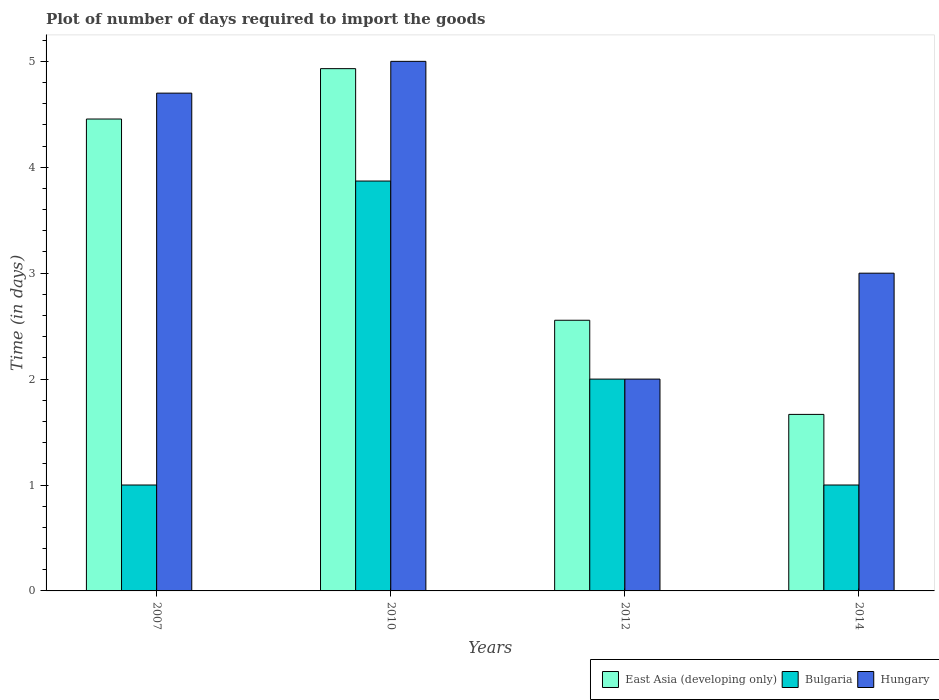How many bars are there on the 2nd tick from the left?
Give a very brief answer. 3. How many bars are there on the 1st tick from the right?
Give a very brief answer. 3. In how many cases, is the number of bars for a given year not equal to the number of legend labels?
Make the answer very short. 0. Across all years, what is the maximum time required to import goods in Bulgaria?
Offer a terse response. 3.87. Across all years, what is the minimum time required to import goods in East Asia (developing only)?
Your answer should be very brief. 1.67. In which year was the time required to import goods in Bulgaria maximum?
Offer a very short reply. 2010. What is the total time required to import goods in East Asia (developing only) in the graph?
Ensure brevity in your answer.  13.61. What is the difference between the time required to import goods in East Asia (developing only) in 2010 and that in 2014?
Keep it short and to the point. 3.26. What is the difference between the time required to import goods in Bulgaria in 2014 and the time required to import goods in East Asia (developing only) in 2012?
Your response must be concise. -1.56. What is the average time required to import goods in Hungary per year?
Keep it short and to the point. 3.67. In the year 2010, what is the difference between the time required to import goods in Hungary and time required to import goods in Bulgaria?
Your answer should be compact. 1.13. In how many years, is the time required to import goods in East Asia (developing only) greater than 2.6 days?
Provide a succinct answer. 2. What is the ratio of the time required to import goods in Hungary in 2007 to that in 2010?
Your response must be concise. 0.94. Is the time required to import goods in Hungary in 2012 less than that in 2014?
Your answer should be compact. Yes. What is the difference between the highest and the second highest time required to import goods in Hungary?
Keep it short and to the point. 0.3. What is the difference between the highest and the lowest time required to import goods in Hungary?
Provide a short and direct response. 3. In how many years, is the time required to import goods in Bulgaria greater than the average time required to import goods in Bulgaria taken over all years?
Your response must be concise. 2. Is the sum of the time required to import goods in East Asia (developing only) in 2007 and 2010 greater than the maximum time required to import goods in Bulgaria across all years?
Your answer should be very brief. Yes. How many years are there in the graph?
Ensure brevity in your answer.  4. What is the difference between two consecutive major ticks on the Y-axis?
Offer a terse response. 1. Are the values on the major ticks of Y-axis written in scientific E-notation?
Your response must be concise. No. Does the graph contain any zero values?
Make the answer very short. No. Does the graph contain grids?
Your response must be concise. No. What is the title of the graph?
Your response must be concise. Plot of number of days required to import the goods. Does "St. Martin (French part)" appear as one of the legend labels in the graph?
Provide a short and direct response. No. What is the label or title of the X-axis?
Make the answer very short. Years. What is the label or title of the Y-axis?
Your answer should be compact. Time (in days). What is the Time (in days) in East Asia (developing only) in 2007?
Your answer should be very brief. 4.46. What is the Time (in days) of Bulgaria in 2007?
Provide a succinct answer. 1. What is the Time (in days) in Hungary in 2007?
Offer a very short reply. 4.7. What is the Time (in days) in East Asia (developing only) in 2010?
Provide a short and direct response. 4.93. What is the Time (in days) of Bulgaria in 2010?
Offer a very short reply. 3.87. What is the Time (in days) in East Asia (developing only) in 2012?
Your response must be concise. 2.56. What is the Time (in days) of Bulgaria in 2012?
Offer a terse response. 2. What is the Time (in days) of East Asia (developing only) in 2014?
Give a very brief answer. 1.67. What is the Time (in days) of Bulgaria in 2014?
Ensure brevity in your answer.  1. Across all years, what is the maximum Time (in days) of East Asia (developing only)?
Provide a succinct answer. 4.93. Across all years, what is the maximum Time (in days) in Bulgaria?
Give a very brief answer. 3.87. Across all years, what is the maximum Time (in days) of Hungary?
Ensure brevity in your answer.  5. Across all years, what is the minimum Time (in days) in East Asia (developing only)?
Provide a short and direct response. 1.67. Across all years, what is the minimum Time (in days) of Bulgaria?
Your response must be concise. 1. Across all years, what is the minimum Time (in days) of Hungary?
Your answer should be very brief. 2. What is the total Time (in days) of East Asia (developing only) in the graph?
Offer a terse response. 13.61. What is the total Time (in days) in Bulgaria in the graph?
Make the answer very short. 7.87. What is the difference between the Time (in days) in East Asia (developing only) in 2007 and that in 2010?
Ensure brevity in your answer.  -0.48. What is the difference between the Time (in days) in Bulgaria in 2007 and that in 2010?
Your answer should be compact. -2.87. What is the difference between the Time (in days) of Hungary in 2007 and that in 2010?
Give a very brief answer. -0.3. What is the difference between the Time (in days) in East Asia (developing only) in 2007 and that in 2012?
Your answer should be compact. 1.9. What is the difference between the Time (in days) in Bulgaria in 2007 and that in 2012?
Provide a succinct answer. -1. What is the difference between the Time (in days) of Hungary in 2007 and that in 2012?
Your answer should be compact. 2.7. What is the difference between the Time (in days) of East Asia (developing only) in 2007 and that in 2014?
Offer a terse response. 2.79. What is the difference between the Time (in days) in Bulgaria in 2007 and that in 2014?
Give a very brief answer. 0. What is the difference between the Time (in days) of Hungary in 2007 and that in 2014?
Your response must be concise. 1.7. What is the difference between the Time (in days) in East Asia (developing only) in 2010 and that in 2012?
Make the answer very short. 2.38. What is the difference between the Time (in days) of Bulgaria in 2010 and that in 2012?
Offer a very short reply. 1.87. What is the difference between the Time (in days) of Hungary in 2010 and that in 2012?
Provide a short and direct response. 3. What is the difference between the Time (in days) in East Asia (developing only) in 2010 and that in 2014?
Ensure brevity in your answer.  3.26. What is the difference between the Time (in days) of Bulgaria in 2010 and that in 2014?
Ensure brevity in your answer.  2.87. What is the difference between the Time (in days) in East Asia (developing only) in 2007 and the Time (in days) in Bulgaria in 2010?
Offer a terse response. 0.59. What is the difference between the Time (in days) in East Asia (developing only) in 2007 and the Time (in days) in Hungary in 2010?
Your response must be concise. -0.54. What is the difference between the Time (in days) in East Asia (developing only) in 2007 and the Time (in days) in Bulgaria in 2012?
Your response must be concise. 2.46. What is the difference between the Time (in days) of East Asia (developing only) in 2007 and the Time (in days) of Hungary in 2012?
Provide a short and direct response. 2.46. What is the difference between the Time (in days) in East Asia (developing only) in 2007 and the Time (in days) in Bulgaria in 2014?
Provide a short and direct response. 3.46. What is the difference between the Time (in days) in East Asia (developing only) in 2007 and the Time (in days) in Hungary in 2014?
Provide a short and direct response. 1.46. What is the difference between the Time (in days) of East Asia (developing only) in 2010 and the Time (in days) of Bulgaria in 2012?
Offer a terse response. 2.93. What is the difference between the Time (in days) in East Asia (developing only) in 2010 and the Time (in days) in Hungary in 2012?
Keep it short and to the point. 2.93. What is the difference between the Time (in days) of Bulgaria in 2010 and the Time (in days) of Hungary in 2012?
Your answer should be very brief. 1.87. What is the difference between the Time (in days) in East Asia (developing only) in 2010 and the Time (in days) in Bulgaria in 2014?
Offer a terse response. 3.93. What is the difference between the Time (in days) of East Asia (developing only) in 2010 and the Time (in days) of Hungary in 2014?
Your response must be concise. 1.93. What is the difference between the Time (in days) in Bulgaria in 2010 and the Time (in days) in Hungary in 2014?
Provide a short and direct response. 0.87. What is the difference between the Time (in days) in East Asia (developing only) in 2012 and the Time (in days) in Bulgaria in 2014?
Offer a very short reply. 1.56. What is the difference between the Time (in days) in East Asia (developing only) in 2012 and the Time (in days) in Hungary in 2014?
Give a very brief answer. -0.44. What is the average Time (in days) in East Asia (developing only) per year?
Provide a short and direct response. 3.4. What is the average Time (in days) of Bulgaria per year?
Your answer should be compact. 1.97. What is the average Time (in days) of Hungary per year?
Your answer should be compact. 3.67. In the year 2007, what is the difference between the Time (in days) in East Asia (developing only) and Time (in days) in Bulgaria?
Make the answer very short. 3.46. In the year 2007, what is the difference between the Time (in days) of East Asia (developing only) and Time (in days) of Hungary?
Make the answer very short. -0.24. In the year 2007, what is the difference between the Time (in days) of Bulgaria and Time (in days) of Hungary?
Give a very brief answer. -3.7. In the year 2010, what is the difference between the Time (in days) in East Asia (developing only) and Time (in days) in Bulgaria?
Ensure brevity in your answer.  1.06. In the year 2010, what is the difference between the Time (in days) of East Asia (developing only) and Time (in days) of Hungary?
Provide a short and direct response. -0.07. In the year 2010, what is the difference between the Time (in days) in Bulgaria and Time (in days) in Hungary?
Keep it short and to the point. -1.13. In the year 2012, what is the difference between the Time (in days) of East Asia (developing only) and Time (in days) of Bulgaria?
Your response must be concise. 0.56. In the year 2012, what is the difference between the Time (in days) of East Asia (developing only) and Time (in days) of Hungary?
Your response must be concise. 0.56. In the year 2012, what is the difference between the Time (in days) of Bulgaria and Time (in days) of Hungary?
Your answer should be very brief. 0. In the year 2014, what is the difference between the Time (in days) in East Asia (developing only) and Time (in days) in Hungary?
Make the answer very short. -1.33. What is the ratio of the Time (in days) of East Asia (developing only) in 2007 to that in 2010?
Your answer should be compact. 0.9. What is the ratio of the Time (in days) of Bulgaria in 2007 to that in 2010?
Your answer should be very brief. 0.26. What is the ratio of the Time (in days) in Hungary in 2007 to that in 2010?
Provide a short and direct response. 0.94. What is the ratio of the Time (in days) of East Asia (developing only) in 2007 to that in 2012?
Provide a short and direct response. 1.74. What is the ratio of the Time (in days) in Bulgaria in 2007 to that in 2012?
Offer a very short reply. 0.5. What is the ratio of the Time (in days) in Hungary in 2007 to that in 2012?
Make the answer very short. 2.35. What is the ratio of the Time (in days) of East Asia (developing only) in 2007 to that in 2014?
Give a very brief answer. 2.67. What is the ratio of the Time (in days) of Bulgaria in 2007 to that in 2014?
Offer a terse response. 1. What is the ratio of the Time (in days) in Hungary in 2007 to that in 2014?
Provide a short and direct response. 1.57. What is the ratio of the Time (in days) in East Asia (developing only) in 2010 to that in 2012?
Keep it short and to the point. 1.93. What is the ratio of the Time (in days) of Bulgaria in 2010 to that in 2012?
Give a very brief answer. 1.94. What is the ratio of the Time (in days) of East Asia (developing only) in 2010 to that in 2014?
Your response must be concise. 2.96. What is the ratio of the Time (in days) of Bulgaria in 2010 to that in 2014?
Offer a very short reply. 3.87. What is the ratio of the Time (in days) of East Asia (developing only) in 2012 to that in 2014?
Provide a short and direct response. 1.53. What is the difference between the highest and the second highest Time (in days) of East Asia (developing only)?
Ensure brevity in your answer.  0.48. What is the difference between the highest and the second highest Time (in days) in Bulgaria?
Give a very brief answer. 1.87. What is the difference between the highest and the second highest Time (in days) in Hungary?
Provide a succinct answer. 0.3. What is the difference between the highest and the lowest Time (in days) in East Asia (developing only)?
Offer a very short reply. 3.26. What is the difference between the highest and the lowest Time (in days) in Bulgaria?
Give a very brief answer. 2.87. 